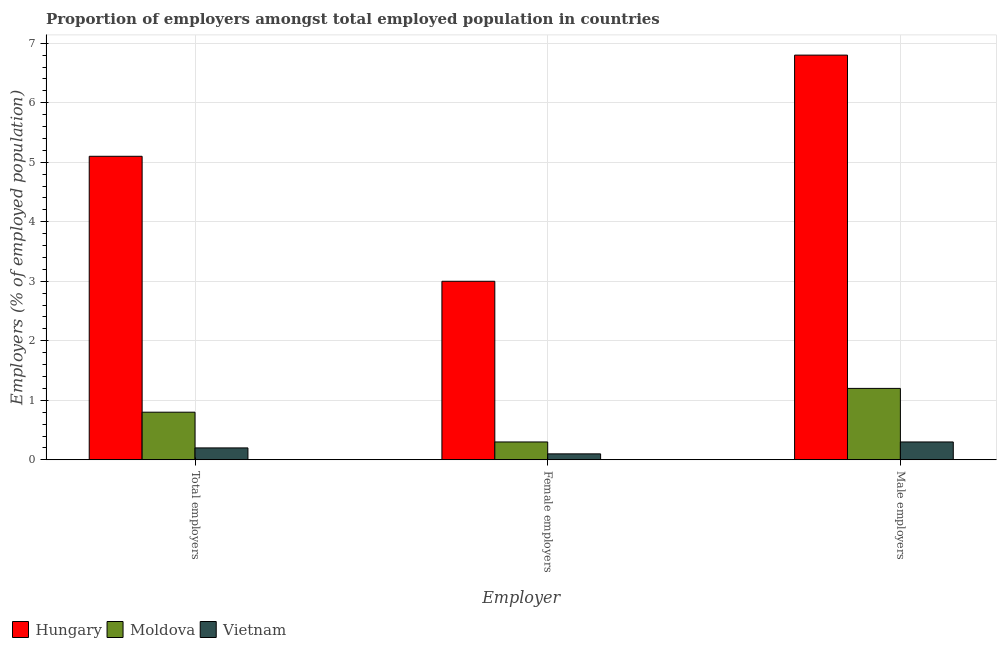How many groups of bars are there?
Your answer should be compact. 3. How many bars are there on the 1st tick from the left?
Keep it short and to the point. 3. What is the label of the 2nd group of bars from the left?
Ensure brevity in your answer.  Female employers. What is the percentage of male employers in Hungary?
Provide a short and direct response. 6.8. Across all countries, what is the maximum percentage of male employers?
Give a very brief answer. 6.8. Across all countries, what is the minimum percentage of total employers?
Keep it short and to the point. 0.2. In which country was the percentage of total employers maximum?
Ensure brevity in your answer.  Hungary. In which country was the percentage of male employers minimum?
Make the answer very short. Vietnam. What is the total percentage of female employers in the graph?
Offer a very short reply. 3.4. What is the difference between the percentage of total employers in Vietnam and that in Moldova?
Offer a very short reply. -0.6. What is the average percentage of male employers per country?
Provide a short and direct response. 2.77. What is the difference between the percentage of total employers and percentage of female employers in Hungary?
Provide a short and direct response. 2.1. In how many countries, is the percentage of total employers greater than 2.4 %?
Your response must be concise. 1. What is the ratio of the percentage of total employers in Hungary to that in Vietnam?
Keep it short and to the point. 25.5. Is the difference between the percentage of female employers in Hungary and Vietnam greater than the difference between the percentage of total employers in Hungary and Vietnam?
Make the answer very short. No. What is the difference between the highest and the second highest percentage of total employers?
Provide a short and direct response. 4.3. What is the difference between the highest and the lowest percentage of total employers?
Offer a very short reply. 4.9. In how many countries, is the percentage of total employers greater than the average percentage of total employers taken over all countries?
Offer a terse response. 1. Is the sum of the percentage of male employers in Moldova and Vietnam greater than the maximum percentage of female employers across all countries?
Your answer should be very brief. No. What does the 2nd bar from the left in Female employers represents?
Your response must be concise. Moldova. What does the 2nd bar from the right in Total employers represents?
Give a very brief answer. Moldova. How many bars are there?
Offer a very short reply. 9. Are all the bars in the graph horizontal?
Your answer should be very brief. No. Does the graph contain grids?
Your answer should be very brief. Yes. Where does the legend appear in the graph?
Provide a succinct answer. Bottom left. What is the title of the graph?
Offer a terse response. Proportion of employers amongst total employed population in countries. What is the label or title of the X-axis?
Provide a short and direct response. Employer. What is the label or title of the Y-axis?
Provide a succinct answer. Employers (% of employed population). What is the Employers (% of employed population) in Hungary in Total employers?
Provide a short and direct response. 5.1. What is the Employers (% of employed population) in Moldova in Total employers?
Your answer should be compact. 0.8. What is the Employers (% of employed population) of Vietnam in Total employers?
Offer a very short reply. 0.2. What is the Employers (% of employed population) in Moldova in Female employers?
Provide a succinct answer. 0.3. What is the Employers (% of employed population) of Vietnam in Female employers?
Give a very brief answer. 0.1. What is the Employers (% of employed population) in Hungary in Male employers?
Offer a terse response. 6.8. What is the Employers (% of employed population) of Moldova in Male employers?
Make the answer very short. 1.2. What is the Employers (% of employed population) of Vietnam in Male employers?
Provide a succinct answer. 0.3. Across all Employer, what is the maximum Employers (% of employed population) of Hungary?
Provide a succinct answer. 6.8. Across all Employer, what is the maximum Employers (% of employed population) in Moldova?
Your answer should be compact. 1.2. Across all Employer, what is the maximum Employers (% of employed population) of Vietnam?
Give a very brief answer. 0.3. Across all Employer, what is the minimum Employers (% of employed population) in Moldova?
Keep it short and to the point. 0.3. Across all Employer, what is the minimum Employers (% of employed population) in Vietnam?
Provide a succinct answer. 0.1. What is the total Employers (% of employed population) in Hungary in the graph?
Provide a succinct answer. 14.9. What is the total Employers (% of employed population) in Moldova in the graph?
Your answer should be compact. 2.3. What is the total Employers (% of employed population) of Vietnam in the graph?
Offer a very short reply. 0.6. What is the difference between the Employers (% of employed population) in Moldova in Total employers and that in Female employers?
Provide a short and direct response. 0.5. What is the difference between the Employers (% of employed population) in Vietnam in Total employers and that in Female employers?
Your response must be concise. 0.1. What is the difference between the Employers (% of employed population) in Moldova in Total employers and that in Male employers?
Offer a very short reply. -0.4. What is the difference between the Employers (% of employed population) of Moldova in Female employers and that in Male employers?
Your response must be concise. -0.9. What is the difference between the Employers (% of employed population) of Hungary in Total employers and the Employers (% of employed population) of Vietnam in Female employers?
Ensure brevity in your answer.  5. What is the difference between the Employers (% of employed population) in Hungary in Total employers and the Employers (% of employed population) in Vietnam in Male employers?
Ensure brevity in your answer.  4.8. What is the difference between the Employers (% of employed population) of Moldova in Female employers and the Employers (% of employed population) of Vietnam in Male employers?
Provide a short and direct response. 0. What is the average Employers (% of employed population) in Hungary per Employer?
Provide a succinct answer. 4.97. What is the average Employers (% of employed population) in Moldova per Employer?
Give a very brief answer. 0.77. What is the difference between the Employers (% of employed population) in Hungary and Employers (% of employed population) in Moldova in Total employers?
Keep it short and to the point. 4.3. What is the difference between the Employers (% of employed population) in Moldova and Employers (% of employed population) in Vietnam in Total employers?
Make the answer very short. 0.6. What is the difference between the Employers (% of employed population) of Hungary and Employers (% of employed population) of Moldova in Female employers?
Ensure brevity in your answer.  2.7. What is the difference between the Employers (% of employed population) of Hungary and Employers (% of employed population) of Vietnam in Female employers?
Keep it short and to the point. 2.9. What is the difference between the Employers (% of employed population) of Moldova and Employers (% of employed population) of Vietnam in Female employers?
Keep it short and to the point. 0.2. What is the ratio of the Employers (% of employed population) in Hungary in Total employers to that in Female employers?
Give a very brief answer. 1.7. What is the ratio of the Employers (% of employed population) in Moldova in Total employers to that in Female employers?
Your answer should be very brief. 2.67. What is the ratio of the Employers (% of employed population) of Hungary in Total employers to that in Male employers?
Make the answer very short. 0.75. What is the ratio of the Employers (% of employed population) in Vietnam in Total employers to that in Male employers?
Make the answer very short. 0.67. What is the ratio of the Employers (% of employed population) of Hungary in Female employers to that in Male employers?
Give a very brief answer. 0.44. What is the ratio of the Employers (% of employed population) of Vietnam in Female employers to that in Male employers?
Provide a short and direct response. 0.33. What is the difference between the highest and the second highest Employers (% of employed population) in Hungary?
Ensure brevity in your answer.  1.7. What is the difference between the highest and the lowest Employers (% of employed population) of Hungary?
Your answer should be compact. 3.8. What is the difference between the highest and the lowest Employers (% of employed population) of Moldova?
Your answer should be compact. 0.9. What is the difference between the highest and the lowest Employers (% of employed population) in Vietnam?
Your response must be concise. 0.2. 